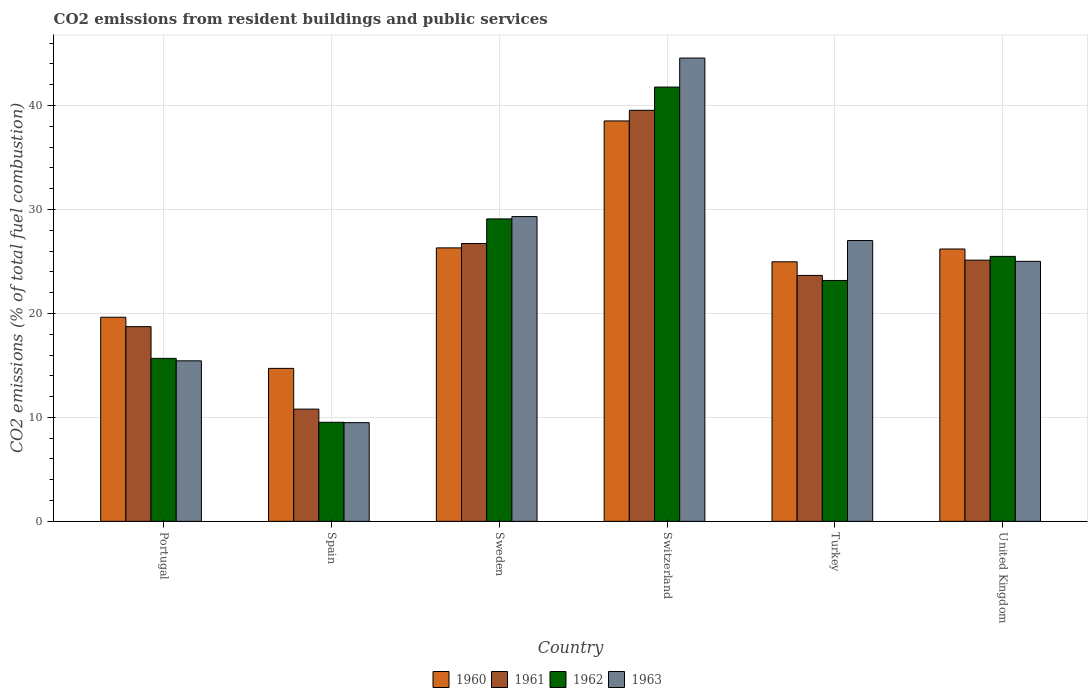How many different coloured bars are there?
Offer a very short reply. 4. Are the number of bars on each tick of the X-axis equal?
Your response must be concise. Yes. How many bars are there on the 3rd tick from the left?
Your answer should be very brief. 4. What is the label of the 5th group of bars from the left?
Keep it short and to the point. Turkey. What is the total CO2 emitted in 1961 in Switzerland?
Your answer should be compact. 39.54. Across all countries, what is the maximum total CO2 emitted in 1961?
Provide a succinct answer. 39.54. Across all countries, what is the minimum total CO2 emitted in 1962?
Your answer should be compact. 9.53. In which country was the total CO2 emitted in 1962 maximum?
Offer a terse response. Switzerland. What is the total total CO2 emitted in 1963 in the graph?
Give a very brief answer. 150.86. What is the difference between the total CO2 emitted in 1960 in Portugal and that in United Kingdom?
Your answer should be very brief. -6.57. What is the difference between the total CO2 emitted in 1960 in Sweden and the total CO2 emitted in 1961 in Portugal?
Keep it short and to the point. 7.58. What is the average total CO2 emitted in 1963 per country?
Provide a short and direct response. 25.14. What is the difference between the total CO2 emitted of/in 1961 and total CO2 emitted of/in 1962 in Spain?
Make the answer very short. 1.27. What is the ratio of the total CO2 emitted in 1962 in Switzerland to that in United Kingdom?
Provide a short and direct response. 1.64. Is the difference between the total CO2 emitted in 1961 in Portugal and Switzerland greater than the difference between the total CO2 emitted in 1962 in Portugal and Switzerland?
Offer a terse response. Yes. What is the difference between the highest and the second highest total CO2 emitted in 1963?
Your response must be concise. -17.56. What is the difference between the highest and the lowest total CO2 emitted in 1962?
Provide a succinct answer. 32.25. In how many countries, is the total CO2 emitted in 1961 greater than the average total CO2 emitted in 1961 taken over all countries?
Offer a very short reply. 3. Is the sum of the total CO2 emitted in 1960 in Spain and Turkey greater than the maximum total CO2 emitted in 1961 across all countries?
Provide a succinct answer. Yes. Is it the case that in every country, the sum of the total CO2 emitted in 1962 and total CO2 emitted in 1961 is greater than the total CO2 emitted in 1960?
Provide a short and direct response. Yes. How many bars are there?
Provide a short and direct response. 24. Are all the bars in the graph horizontal?
Offer a very short reply. No. Are the values on the major ticks of Y-axis written in scientific E-notation?
Offer a terse response. No. Where does the legend appear in the graph?
Your answer should be compact. Bottom center. How many legend labels are there?
Your answer should be very brief. 4. What is the title of the graph?
Offer a terse response. CO2 emissions from resident buildings and public services. Does "1995" appear as one of the legend labels in the graph?
Give a very brief answer. No. What is the label or title of the X-axis?
Keep it short and to the point. Country. What is the label or title of the Y-axis?
Your answer should be compact. CO2 emissions (% of total fuel combustion). What is the CO2 emissions (% of total fuel combustion) in 1960 in Portugal?
Ensure brevity in your answer.  19.64. What is the CO2 emissions (% of total fuel combustion) of 1961 in Portugal?
Your answer should be compact. 18.73. What is the CO2 emissions (% of total fuel combustion) of 1962 in Portugal?
Your response must be concise. 15.68. What is the CO2 emissions (% of total fuel combustion) in 1963 in Portugal?
Ensure brevity in your answer.  15.44. What is the CO2 emissions (% of total fuel combustion) in 1960 in Spain?
Offer a terse response. 14.72. What is the CO2 emissions (% of total fuel combustion) in 1961 in Spain?
Ensure brevity in your answer.  10.8. What is the CO2 emissions (% of total fuel combustion) of 1962 in Spain?
Provide a short and direct response. 9.53. What is the CO2 emissions (% of total fuel combustion) in 1963 in Spain?
Your response must be concise. 9.5. What is the CO2 emissions (% of total fuel combustion) of 1960 in Sweden?
Your answer should be very brief. 26.31. What is the CO2 emissions (% of total fuel combustion) of 1961 in Sweden?
Provide a short and direct response. 26.73. What is the CO2 emissions (% of total fuel combustion) in 1962 in Sweden?
Your answer should be compact. 29.1. What is the CO2 emissions (% of total fuel combustion) in 1963 in Sweden?
Provide a short and direct response. 29.32. What is the CO2 emissions (% of total fuel combustion) of 1960 in Switzerland?
Provide a short and direct response. 38.52. What is the CO2 emissions (% of total fuel combustion) of 1961 in Switzerland?
Make the answer very short. 39.54. What is the CO2 emissions (% of total fuel combustion) of 1962 in Switzerland?
Your response must be concise. 41.78. What is the CO2 emissions (% of total fuel combustion) in 1963 in Switzerland?
Your response must be concise. 44.57. What is the CO2 emissions (% of total fuel combustion) in 1960 in Turkey?
Make the answer very short. 24.97. What is the CO2 emissions (% of total fuel combustion) of 1961 in Turkey?
Give a very brief answer. 23.66. What is the CO2 emissions (% of total fuel combustion) in 1962 in Turkey?
Keep it short and to the point. 23.17. What is the CO2 emissions (% of total fuel combustion) in 1963 in Turkey?
Keep it short and to the point. 27.01. What is the CO2 emissions (% of total fuel combustion) of 1960 in United Kingdom?
Provide a succinct answer. 26.2. What is the CO2 emissions (% of total fuel combustion) in 1961 in United Kingdom?
Make the answer very short. 25.13. What is the CO2 emissions (% of total fuel combustion) in 1962 in United Kingdom?
Provide a short and direct response. 25.49. What is the CO2 emissions (% of total fuel combustion) in 1963 in United Kingdom?
Provide a short and direct response. 25.01. Across all countries, what is the maximum CO2 emissions (% of total fuel combustion) of 1960?
Your answer should be very brief. 38.52. Across all countries, what is the maximum CO2 emissions (% of total fuel combustion) of 1961?
Provide a short and direct response. 39.54. Across all countries, what is the maximum CO2 emissions (% of total fuel combustion) in 1962?
Your answer should be very brief. 41.78. Across all countries, what is the maximum CO2 emissions (% of total fuel combustion) of 1963?
Your answer should be compact. 44.57. Across all countries, what is the minimum CO2 emissions (% of total fuel combustion) of 1960?
Ensure brevity in your answer.  14.72. Across all countries, what is the minimum CO2 emissions (% of total fuel combustion) of 1961?
Your response must be concise. 10.8. Across all countries, what is the minimum CO2 emissions (% of total fuel combustion) of 1962?
Your response must be concise. 9.53. Across all countries, what is the minimum CO2 emissions (% of total fuel combustion) in 1963?
Make the answer very short. 9.5. What is the total CO2 emissions (% of total fuel combustion) of 1960 in the graph?
Your response must be concise. 150.36. What is the total CO2 emissions (% of total fuel combustion) of 1961 in the graph?
Provide a succinct answer. 144.59. What is the total CO2 emissions (% of total fuel combustion) in 1962 in the graph?
Provide a succinct answer. 144.75. What is the total CO2 emissions (% of total fuel combustion) in 1963 in the graph?
Provide a succinct answer. 150.86. What is the difference between the CO2 emissions (% of total fuel combustion) in 1960 in Portugal and that in Spain?
Keep it short and to the point. 4.92. What is the difference between the CO2 emissions (% of total fuel combustion) of 1961 in Portugal and that in Spain?
Give a very brief answer. 7.93. What is the difference between the CO2 emissions (% of total fuel combustion) in 1962 in Portugal and that in Spain?
Your response must be concise. 6.15. What is the difference between the CO2 emissions (% of total fuel combustion) of 1963 in Portugal and that in Spain?
Your response must be concise. 5.95. What is the difference between the CO2 emissions (% of total fuel combustion) of 1960 in Portugal and that in Sweden?
Offer a very short reply. -6.67. What is the difference between the CO2 emissions (% of total fuel combustion) in 1961 in Portugal and that in Sweden?
Your answer should be compact. -8. What is the difference between the CO2 emissions (% of total fuel combustion) of 1962 in Portugal and that in Sweden?
Ensure brevity in your answer.  -13.42. What is the difference between the CO2 emissions (% of total fuel combustion) in 1963 in Portugal and that in Sweden?
Give a very brief answer. -13.88. What is the difference between the CO2 emissions (% of total fuel combustion) of 1960 in Portugal and that in Switzerland?
Offer a very short reply. -18.88. What is the difference between the CO2 emissions (% of total fuel combustion) of 1961 in Portugal and that in Switzerland?
Ensure brevity in your answer.  -20.81. What is the difference between the CO2 emissions (% of total fuel combustion) in 1962 in Portugal and that in Switzerland?
Offer a very short reply. -26.1. What is the difference between the CO2 emissions (% of total fuel combustion) of 1963 in Portugal and that in Switzerland?
Keep it short and to the point. -29.13. What is the difference between the CO2 emissions (% of total fuel combustion) of 1960 in Portugal and that in Turkey?
Your response must be concise. -5.33. What is the difference between the CO2 emissions (% of total fuel combustion) in 1961 in Portugal and that in Turkey?
Ensure brevity in your answer.  -4.93. What is the difference between the CO2 emissions (% of total fuel combustion) in 1962 in Portugal and that in Turkey?
Provide a short and direct response. -7.5. What is the difference between the CO2 emissions (% of total fuel combustion) in 1963 in Portugal and that in Turkey?
Offer a terse response. -11.57. What is the difference between the CO2 emissions (% of total fuel combustion) of 1960 in Portugal and that in United Kingdom?
Ensure brevity in your answer.  -6.57. What is the difference between the CO2 emissions (% of total fuel combustion) of 1961 in Portugal and that in United Kingdom?
Make the answer very short. -6.4. What is the difference between the CO2 emissions (% of total fuel combustion) in 1962 in Portugal and that in United Kingdom?
Your answer should be compact. -9.81. What is the difference between the CO2 emissions (% of total fuel combustion) in 1963 in Portugal and that in United Kingdom?
Ensure brevity in your answer.  -9.57. What is the difference between the CO2 emissions (% of total fuel combustion) of 1960 in Spain and that in Sweden?
Keep it short and to the point. -11.59. What is the difference between the CO2 emissions (% of total fuel combustion) of 1961 in Spain and that in Sweden?
Provide a short and direct response. -15.93. What is the difference between the CO2 emissions (% of total fuel combustion) of 1962 in Spain and that in Sweden?
Make the answer very short. -19.57. What is the difference between the CO2 emissions (% of total fuel combustion) in 1963 in Spain and that in Sweden?
Offer a very short reply. -19.82. What is the difference between the CO2 emissions (% of total fuel combustion) of 1960 in Spain and that in Switzerland?
Offer a terse response. -23.8. What is the difference between the CO2 emissions (% of total fuel combustion) of 1961 in Spain and that in Switzerland?
Ensure brevity in your answer.  -28.75. What is the difference between the CO2 emissions (% of total fuel combustion) of 1962 in Spain and that in Switzerland?
Provide a short and direct response. -32.25. What is the difference between the CO2 emissions (% of total fuel combustion) of 1963 in Spain and that in Switzerland?
Provide a short and direct response. -35.07. What is the difference between the CO2 emissions (% of total fuel combustion) in 1960 in Spain and that in Turkey?
Give a very brief answer. -10.25. What is the difference between the CO2 emissions (% of total fuel combustion) in 1961 in Spain and that in Turkey?
Give a very brief answer. -12.86. What is the difference between the CO2 emissions (% of total fuel combustion) in 1962 in Spain and that in Turkey?
Make the answer very short. -13.64. What is the difference between the CO2 emissions (% of total fuel combustion) of 1963 in Spain and that in Turkey?
Your response must be concise. -17.52. What is the difference between the CO2 emissions (% of total fuel combustion) of 1960 in Spain and that in United Kingdom?
Your response must be concise. -11.49. What is the difference between the CO2 emissions (% of total fuel combustion) of 1961 in Spain and that in United Kingdom?
Offer a terse response. -14.33. What is the difference between the CO2 emissions (% of total fuel combustion) in 1962 in Spain and that in United Kingdom?
Ensure brevity in your answer.  -15.96. What is the difference between the CO2 emissions (% of total fuel combustion) of 1963 in Spain and that in United Kingdom?
Your answer should be very brief. -15.52. What is the difference between the CO2 emissions (% of total fuel combustion) in 1960 in Sweden and that in Switzerland?
Your response must be concise. -12.21. What is the difference between the CO2 emissions (% of total fuel combustion) of 1961 in Sweden and that in Switzerland?
Your answer should be very brief. -12.81. What is the difference between the CO2 emissions (% of total fuel combustion) of 1962 in Sweden and that in Switzerland?
Offer a terse response. -12.68. What is the difference between the CO2 emissions (% of total fuel combustion) of 1963 in Sweden and that in Switzerland?
Give a very brief answer. -15.25. What is the difference between the CO2 emissions (% of total fuel combustion) of 1960 in Sweden and that in Turkey?
Your response must be concise. 1.34. What is the difference between the CO2 emissions (% of total fuel combustion) in 1961 in Sweden and that in Turkey?
Your answer should be very brief. 3.07. What is the difference between the CO2 emissions (% of total fuel combustion) in 1962 in Sweden and that in Turkey?
Your answer should be very brief. 5.92. What is the difference between the CO2 emissions (% of total fuel combustion) of 1963 in Sweden and that in Turkey?
Your answer should be compact. 2.3. What is the difference between the CO2 emissions (% of total fuel combustion) of 1960 in Sweden and that in United Kingdom?
Your response must be concise. 0.11. What is the difference between the CO2 emissions (% of total fuel combustion) in 1961 in Sweden and that in United Kingdom?
Your response must be concise. 1.6. What is the difference between the CO2 emissions (% of total fuel combustion) in 1962 in Sweden and that in United Kingdom?
Give a very brief answer. 3.61. What is the difference between the CO2 emissions (% of total fuel combustion) in 1963 in Sweden and that in United Kingdom?
Offer a terse response. 4.3. What is the difference between the CO2 emissions (% of total fuel combustion) of 1960 in Switzerland and that in Turkey?
Provide a succinct answer. 13.55. What is the difference between the CO2 emissions (% of total fuel combustion) in 1961 in Switzerland and that in Turkey?
Make the answer very short. 15.88. What is the difference between the CO2 emissions (% of total fuel combustion) of 1962 in Switzerland and that in Turkey?
Make the answer very short. 18.6. What is the difference between the CO2 emissions (% of total fuel combustion) of 1963 in Switzerland and that in Turkey?
Provide a short and direct response. 17.56. What is the difference between the CO2 emissions (% of total fuel combustion) of 1960 in Switzerland and that in United Kingdom?
Ensure brevity in your answer.  12.32. What is the difference between the CO2 emissions (% of total fuel combustion) of 1961 in Switzerland and that in United Kingdom?
Offer a terse response. 14.42. What is the difference between the CO2 emissions (% of total fuel combustion) of 1962 in Switzerland and that in United Kingdom?
Provide a short and direct response. 16.29. What is the difference between the CO2 emissions (% of total fuel combustion) of 1963 in Switzerland and that in United Kingdom?
Make the answer very short. 19.56. What is the difference between the CO2 emissions (% of total fuel combustion) of 1960 in Turkey and that in United Kingdom?
Provide a succinct answer. -1.23. What is the difference between the CO2 emissions (% of total fuel combustion) of 1961 in Turkey and that in United Kingdom?
Keep it short and to the point. -1.47. What is the difference between the CO2 emissions (% of total fuel combustion) in 1962 in Turkey and that in United Kingdom?
Provide a succinct answer. -2.32. What is the difference between the CO2 emissions (% of total fuel combustion) of 1960 in Portugal and the CO2 emissions (% of total fuel combustion) of 1961 in Spain?
Your answer should be compact. 8.84. What is the difference between the CO2 emissions (% of total fuel combustion) in 1960 in Portugal and the CO2 emissions (% of total fuel combustion) in 1962 in Spain?
Your answer should be compact. 10.11. What is the difference between the CO2 emissions (% of total fuel combustion) in 1960 in Portugal and the CO2 emissions (% of total fuel combustion) in 1963 in Spain?
Offer a terse response. 10.14. What is the difference between the CO2 emissions (% of total fuel combustion) in 1961 in Portugal and the CO2 emissions (% of total fuel combustion) in 1962 in Spain?
Your response must be concise. 9.2. What is the difference between the CO2 emissions (% of total fuel combustion) in 1961 in Portugal and the CO2 emissions (% of total fuel combustion) in 1963 in Spain?
Ensure brevity in your answer.  9.23. What is the difference between the CO2 emissions (% of total fuel combustion) of 1962 in Portugal and the CO2 emissions (% of total fuel combustion) of 1963 in Spain?
Keep it short and to the point. 6.18. What is the difference between the CO2 emissions (% of total fuel combustion) in 1960 in Portugal and the CO2 emissions (% of total fuel combustion) in 1961 in Sweden?
Your response must be concise. -7.09. What is the difference between the CO2 emissions (% of total fuel combustion) in 1960 in Portugal and the CO2 emissions (% of total fuel combustion) in 1962 in Sweden?
Your answer should be compact. -9.46. What is the difference between the CO2 emissions (% of total fuel combustion) of 1960 in Portugal and the CO2 emissions (% of total fuel combustion) of 1963 in Sweden?
Your answer should be very brief. -9.68. What is the difference between the CO2 emissions (% of total fuel combustion) of 1961 in Portugal and the CO2 emissions (% of total fuel combustion) of 1962 in Sweden?
Provide a short and direct response. -10.36. What is the difference between the CO2 emissions (% of total fuel combustion) of 1961 in Portugal and the CO2 emissions (% of total fuel combustion) of 1963 in Sweden?
Your response must be concise. -10.59. What is the difference between the CO2 emissions (% of total fuel combustion) of 1962 in Portugal and the CO2 emissions (% of total fuel combustion) of 1963 in Sweden?
Ensure brevity in your answer.  -13.64. What is the difference between the CO2 emissions (% of total fuel combustion) in 1960 in Portugal and the CO2 emissions (% of total fuel combustion) in 1961 in Switzerland?
Give a very brief answer. -19.91. What is the difference between the CO2 emissions (% of total fuel combustion) of 1960 in Portugal and the CO2 emissions (% of total fuel combustion) of 1962 in Switzerland?
Make the answer very short. -22.14. What is the difference between the CO2 emissions (% of total fuel combustion) of 1960 in Portugal and the CO2 emissions (% of total fuel combustion) of 1963 in Switzerland?
Give a very brief answer. -24.93. What is the difference between the CO2 emissions (% of total fuel combustion) in 1961 in Portugal and the CO2 emissions (% of total fuel combustion) in 1962 in Switzerland?
Ensure brevity in your answer.  -23.05. What is the difference between the CO2 emissions (% of total fuel combustion) of 1961 in Portugal and the CO2 emissions (% of total fuel combustion) of 1963 in Switzerland?
Provide a succinct answer. -25.84. What is the difference between the CO2 emissions (% of total fuel combustion) of 1962 in Portugal and the CO2 emissions (% of total fuel combustion) of 1963 in Switzerland?
Your answer should be very brief. -28.89. What is the difference between the CO2 emissions (% of total fuel combustion) of 1960 in Portugal and the CO2 emissions (% of total fuel combustion) of 1961 in Turkey?
Your response must be concise. -4.02. What is the difference between the CO2 emissions (% of total fuel combustion) of 1960 in Portugal and the CO2 emissions (% of total fuel combustion) of 1962 in Turkey?
Your answer should be very brief. -3.54. What is the difference between the CO2 emissions (% of total fuel combustion) of 1960 in Portugal and the CO2 emissions (% of total fuel combustion) of 1963 in Turkey?
Give a very brief answer. -7.38. What is the difference between the CO2 emissions (% of total fuel combustion) of 1961 in Portugal and the CO2 emissions (% of total fuel combustion) of 1962 in Turkey?
Your answer should be very brief. -4.44. What is the difference between the CO2 emissions (% of total fuel combustion) of 1961 in Portugal and the CO2 emissions (% of total fuel combustion) of 1963 in Turkey?
Offer a terse response. -8.28. What is the difference between the CO2 emissions (% of total fuel combustion) in 1962 in Portugal and the CO2 emissions (% of total fuel combustion) in 1963 in Turkey?
Your answer should be very brief. -11.34. What is the difference between the CO2 emissions (% of total fuel combustion) in 1960 in Portugal and the CO2 emissions (% of total fuel combustion) in 1961 in United Kingdom?
Offer a terse response. -5.49. What is the difference between the CO2 emissions (% of total fuel combustion) of 1960 in Portugal and the CO2 emissions (% of total fuel combustion) of 1962 in United Kingdom?
Ensure brevity in your answer.  -5.85. What is the difference between the CO2 emissions (% of total fuel combustion) in 1960 in Portugal and the CO2 emissions (% of total fuel combustion) in 1963 in United Kingdom?
Keep it short and to the point. -5.38. What is the difference between the CO2 emissions (% of total fuel combustion) in 1961 in Portugal and the CO2 emissions (% of total fuel combustion) in 1962 in United Kingdom?
Provide a succinct answer. -6.76. What is the difference between the CO2 emissions (% of total fuel combustion) of 1961 in Portugal and the CO2 emissions (% of total fuel combustion) of 1963 in United Kingdom?
Keep it short and to the point. -6.28. What is the difference between the CO2 emissions (% of total fuel combustion) of 1962 in Portugal and the CO2 emissions (% of total fuel combustion) of 1963 in United Kingdom?
Ensure brevity in your answer.  -9.34. What is the difference between the CO2 emissions (% of total fuel combustion) of 1960 in Spain and the CO2 emissions (% of total fuel combustion) of 1961 in Sweden?
Make the answer very short. -12.01. What is the difference between the CO2 emissions (% of total fuel combustion) in 1960 in Spain and the CO2 emissions (% of total fuel combustion) in 1962 in Sweden?
Offer a very short reply. -14.38. What is the difference between the CO2 emissions (% of total fuel combustion) of 1960 in Spain and the CO2 emissions (% of total fuel combustion) of 1963 in Sweden?
Give a very brief answer. -14.6. What is the difference between the CO2 emissions (% of total fuel combustion) of 1961 in Spain and the CO2 emissions (% of total fuel combustion) of 1962 in Sweden?
Your answer should be compact. -18.3. What is the difference between the CO2 emissions (% of total fuel combustion) of 1961 in Spain and the CO2 emissions (% of total fuel combustion) of 1963 in Sweden?
Ensure brevity in your answer.  -18.52. What is the difference between the CO2 emissions (% of total fuel combustion) in 1962 in Spain and the CO2 emissions (% of total fuel combustion) in 1963 in Sweden?
Provide a short and direct response. -19.79. What is the difference between the CO2 emissions (% of total fuel combustion) in 1960 in Spain and the CO2 emissions (% of total fuel combustion) in 1961 in Switzerland?
Offer a terse response. -24.83. What is the difference between the CO2 emissions (% of total fuel combustion) of 1960 in Spain and the CO2 emissions (% of total fuel combustion) of 1962 in Switzerland?
Your answer should be compact. -27.06. What is the difference between the CO2 emissions (% of total fuel combustion) in 1960 in Spain and the CO2 emissions (% of total fuel combustion) in 1963 in Switzerland?
Your answer should be compact. -29.85. What is the difference between the CO2 emissions (% of total fuel combustion) of 1961 in Spain and the CO2 emissions (% of total fuel combustion) of 1962 in Switzerland?
Keep it short and to the point. -30.98. What is the difference between the CO2 emissions (% of total fuel combustion) of 1961 in Spain and the CO2 emissions (% of total fuel combustion) of 1963 in Switzerland?
Provide a short and direct response. -33.77. What is the difference between the CO2 emissions (% of total fuel combustion) of 1962 in Spain and the CO2 emissions (% of total fuel combustion) of 1963 in Switzerland?
Your answer should be very brief. -35.04. What is the difference between the CO2 emissions (% of total fuel combustion) of 1960 in Spain and the CO2 emissions (% of total fuel combustion) of 1961 in Turkey?
Your answer should be very brief. -8.94. What is the difference between the CO2 emissions (% of total fuel combustion) of 1960 in Spain and the CO2 emissions (% of total fuel combustion) of 1962 in Turkey?
Ensure brevity in your answer.  -8.46. What is the difference between the CO2 emissions (% of total fuel combustion) of 1960 in Spain and the CO2 emissions (% of total fuel combustion) of 1963 in Turkey?
Your answer should be compact. -12.3. What is the difference between the CO2 emissions (% of total fuel combustion) in 1961 in Spain and the CO2 emissions (% of total fuel combustion) in 1962 in Turkey?
Provide a succinct answer. -12.38. What is the difference between the CO2 emissions (% of total fuel combustion) in 1961 in Spain and the CO2 emissions (% of total fuel combustion) in 1963 in Turkey?
Offer a very short reply. -16.22. What is the difference between the CO2 emissions (% of total fuel combustion) in 1962 in Spain and the CO2 emissions (% of total fuel combustion) in 1963 in Turkey?
Make the answer very short. -17.48. What is the difference between the CO2 emissions (% of total fuel combustion) in 1960 in Spain and the CO2 emissions (% of total fuel combustion) in 1961 in United Kingdom?
Your answer should be very brief. -10.41. What is the difference between the CO2 emissions (% of total fuel combustion) in 1960 in Spain and the CO2 emissions (% of total fuel combustion) in 1962 in United Kingdom?
Offer a very short reply. -10.77. What is the difference between the CO2 emissions (% of total fuel combustion) of 1960 in Spain and the CO2 emissions (% of total fuel combustion) of 1963 in United Kingdom?
Your answer should be compact. -10.3. What is the difference between the CO2 emissions (% of total fuel combustion) in 1961 in Spain and the CO2 emissions (% of total fuel combustion) in 1962 in United Kingdom?
Your answer should be compact. -14.69. What is the difference between the CO2 emissions (% of total fuel combustion) in 1961 in Spain and the CO2 emissions (% of total fuel combustion) in 1963 in United Kingdom?
Provide a succinct answer. -14.22. What is the difference between the CO2 emissions (% of total fuel combustion) in 1962 in Spain and the CO2 emissions (% of total fuel combustion) in 1963 in United Kingdom?
Offer a very short reply. -15.48. What is the difference between the CO2 emissions (% of total fuel combustion) in 1960 in Sweden and the CO2 emissions (% of total fuel combustion) in 1961 in Switzerland?
Your answer should be compact. -13.23. What is the difference between the CO2 emissions (% of total fuel combustion) in 1960 in Sweden and the CO2 emissions (% of total fuel combustion) in 1962 in Switzerland?
Provide a succinct answer. -15.47. What is the difference between the CO2 emissions (% of total fuel combustion) of 1960 in Sweden and the CO2 emissions (% of total fuel combustion) of 1963 in Switzerland?
Keep it short and to the point. -18.26. What is the difference between the CO2 emissions (% of total fuel combustion) of 1961 in Sweden and the CO2 emissions (% of total fuel combustion) of 1962 in Switzerland?
Provide a succinct answer. -15.05. What is the difference between the CO2 emissions (% of total fuel combustion) of 1961 in Sweden and the CO2 emissions (% of total fuel combustion) of 1963 in Switzerland?
Your response must be concise. -17.84. What is the difference between the CO2 emissions (% of total fuel combustion) of 1962 in Sweden and the CO2 emissions (% of total fuel combustion) of 1963 in Switzerland?
Your response must be concise. -15.47. What is the difference between the CO2 emissions (% of total fuel combustion) of 1960 in Sweden and the CO2 emissions (% of total fuel combustion) of 1961 in Turkey?
Keep it short and to the point. 2.65. What is the difference between the CO2 emissions (% of total fuel combustion) of 1960 in Sweden and the CO2 emissions (% of total fuel combustion) of 1962 in Turkey?
Make the answer very short. 3.14. What is the difference between the CO2 emissions (% of total fuel combustion) in 1960 in Sweden and the CO2 emissions (% of total fuel combustion) in 1963 in Turkey?
Your response must be concise. -0.71. What is the difference between the CO2 emissions (% of total fuel combustion) in 1961 in Sweden and the CO2 emissions (% of total fuel combustion) in 1962 in Turkey?
Keep it short and to the point. 3.56. What is the difference between the CO2 emissions (% of total fuel combustion) in 1961 in Sweden and the CO2 emissions (% of total fuel combustion) in 1963 in Turkey?
Offer a terse response. -0.29. What is the difference between the CO2 emissions (% of total fuel combustion) in 1962 in Sweden and the CO2 emissions (% of total fuel combustion) in 1963 in Turkey?
Offer a very short reply. 2.08. What is the difference between the CO2 emissions (% of total fuel combustion) of 1960 in Sweden and the CO2 emissions (% of total fuel combustion) of 1961 in United Kingdom?
Ensure brevity in your answer.  1.18. What is the difference between the CO2 emissions (% of total fuel combustion) of 1960 in Sweden and the CO2 emissions (% of total fuel combustion) of 1962 in United Kingdom?
Make the answer very short. 0.82. What is the difference between the CO2 emissions (% of total fuel combustion) of 1960 in Sweden and the CO2 emissions (% of total fuel combustion) of 1963 in United Kingdom?
Your response must be concise. 1.29. What is the difference between the CO2 emissions (% of total fuel combustion) in 1961 in Sweden and the CO2 emissions (% of total fuel combustion) in 1962 in United Kingdom?
Provide a short and direct response. 1.24. What is the difference between the CO2 emissions (% of total fuel combustion) in 1961 in Sweden and the CO2 emissions (% of total fuel combustion) in 1963 in United Kingdom?
Your answer should be very brief. 1.71. What is the difference between the CO2 emissions (% of total fuel combustion) of 1962 in Sweden and the CO2 emissions (% of total fuel combustion) of 1963 in United Kingdom?
Provide a short and direct response. 4.08. What is the difference between the CO2 emissions (% of total fuel combustion) in 1960 in Switzerland and the CO2 emissions (% of total fuel combustion) in 1961 in Turkey?
Give a very brief answer. 14.86. What is the difference between the CO2 emissions (% of total fuel combustion) of 1960 in Switzerland and the CO2 emissions (% of total fuel combustion) of 1962 in Turkey?
Give a very brief answer. 15.35. What is the difference between the CO2 emissions (% of total fuel combustion) of 1960 in Switzerland and the CO2 emissions (% of total fuel combustion) of 1963 in Turkey?
Ensure brevity in your answer.  11.51. What is the difference between the CO2 emissions (% of total fuel combustion) in 1961 in Switzerland and the CO2 emissions (% of total fuel combustion) in 1962 in Turkey?
Make the answer very short. 16.37. What is the difference between the CO2 emissions (% of total fuel combustion) of 1961 in Switzerland and the CO2 emissions (% of total fuel combustion) of 1963 in Turkey?
Provide a short and direct response. 12.53. What is the difference between the CO2 emissions (% of total fuel combustion) of 1962 in Switzerland and the CO2 emissions (% of total fuel combustion) of 1963 in Turkey?
Your response must be concise. 14.76. What is the difference between the CO2 emissions (% of total fuel combustion) in 1960 in Switzerland and the CO2 emissions (% of total fuel combustion) in 1961 in United Kingdom?
Keep it short and to the point. 13.39. What is the difference between the CO2 emissions (% of total fuel combustion) in 1960 in Switzerland and the CO2 emissions (% of total fuel combustion) in 1962 in United Kingdom?
Offer a very short reply. 13.03. What is the difference between the CO2 emissions (% of total fuel combustion) in 1960 in Switzerland and the CO2 emissions (% of total fuel combustion) in 1963 in United Kingdom?
Keep it short and to the point. 13.51. What is the difference between the CO2 emissions (% of total fuel combustion) in 1961 in Switzerland and the CO2 emissions (% of total fuel combustion) in 1962 in United Kingdom?
Offer a terse response. 14.05. What is the difference between the CO2 emissions (% of total fuel combustion) of 1961 in Switzerland and the CO2 emissions (% of total fuel combustion) of 1963 in United Kingdom?
Provide a short and direct response. 14.53. What is the difference between the CO2 emissions (% of total fuel combustion) of 1962 in Switzerland and the CO2 emissions (% of total fuel combustion) of 1963 in United Kingdom?
Keep it short and to the point. 16.76. What is the difference between the CO2 emissions (% of total fuel combustion) in 1960 in Turkey and the CO2 emissions (% of total fuel combustion) in 1961 in United Kingdom?
Offer a very short reply. -0.16. What is the difference between the CO2 emissions (% of total fuel combustion) in 1960 in Turkey and the CO2 emissions (% of total fuel combustion) in 1962 in United Kingdom?
Your response must be concise. -0.52. What is the difference between the CO2 emissions (% of total fuel combustion) in 1960 in Turkey and the CO2 emissions (% of total fuel combustion) in 1963 in United Kingdom?
Make the answer very short. -0.05. What is the difference between the CO2 emissions (% of total fuel combustion) of 1961 in Turkey and the CO2 emissions (% of total fuel combustion) of 1962 in United Kingdom?
Ensure brevity in your answer.  -1.83. What is the difference between the CO2 emissions (% of total fuel combustion) of 1961 in Turkey and the CO2 emissions (% of total fuel combustion) of 1963 in United Kingdom?
Offer a very short reply. -1.35. What is the difference between the CO2 emissions (% of total fuel combustion) of 1962 in Turkey and the CO2 emissions (% of total fuel combustion) of 1963 in United Kingdom?
Make the answer very short. -1.84. What is the average CO2 emissions (% of total fuel combustion) of 1960 per country?
Your response must be concise. 25.06. What is the average CO2 emissions (% of total fuel combustion) in 1961 per country?
Your response must be concise. 24.1. What is the average CO2 emissions (% of total fuel combustion) in 1962 per country?
Keep it short and to the point. 24.12. What is the average CO2 emissions (% of total fuel combustion) of 1963 per country?
Your answer should be very brief. 25.14. What is the difference between the CO2 emissions (% of total fuel combustion) of 1960 and CO2 emissions (% of total fuel combustion) of 1961 in Portugal?
Offer a terse response. 0.91. What is the difference between the CO2 emissions (% of total fuel combustion) of 1960 and CO2 emissions (% of total fuel combustion) of 1962 in Portugal?
Give a very brief answer. 3.96. What is the difference between the CO2 emissions (% of total fuel combustion) in 1960 and CO2 emissions (% of total fuel combustion) in 1963 in Portugal?
Your answer should be compact. 4.19. What is the difference between the CO2 emissions (% of total fuel combustion) of 1961 and CO2 emissions (% of total fuel combustion) of 1962 in Portugal?
Your answer should be very brief. 3.05. What is the difference between the CO2 emissions (% of total fuel combustion) in 1961 and CO2 emissions (% of total fuel combustion) in 1963 in Portugal?
Make the answer very short. 3.29. What is the difference between the CO2 emissions (% of total fuel combustion) of 1962 and CO2 emissions (% of total fuel combustion) of 1963 in Portugal?
Provide a short and direct response. 0.23. What is the difference between the CO2 emissions (% of total fuel combustion) of 1960 and CO2 emissions (% of total fuel combustion) of 1961 in Spain?
Provide a short and direct response. 3.92. What is the difference between the CO2 emissions (% of total fuel combustion) of 1960 and CO2 emissions (% of total fuel combustion) of 1962 in Spain?
Your answer should be compact. 5.19. What is the difference between the CO2 emissions (% of total fuel combustion) in 1960 and CO2 emissions (% of total fuel combustion) in 1963 in Spain?
Ensure brevity in your answer.  5.22. What is the difference between the CO2 emissions (% of total fuel combustion) of 1961 and CO2 emissions (% of total fuel combustion) of 1962 in Spain?
Your response must be concise. 1.27. What is the difference between the CO2 emissions (% of total fuel combustion) of 1961 and CO2 emissions (% of total fuel combustion) of 1963 in Spain?
Offer a very short reply. 1.3. What is the difference between the CO2 emissions (% of total fuel combustion) in 1962 and CO2 emissions (% of total fuel combustion) in 1963 in Spain?
Keep it short and to the point. 0.03. What is the difference between the CO2 emissions (% of total fuel combustion) of 1960 and CO2 emissions (% of total fuel combustion) of 1961 in Sweden?
Your answer should be compact. -0.42. What is the difference between the CO2 emissions (% of total fuel combustion) of 1960 and CO2 emissions (% of total fuel combustion) of 1962 in Sweden?
Your response must be concise. -2.79. What is the difference between the CO2 emissions (% of total fuel combustion) in 1960 and CO2 emissions (% of total fuel combustion) in 1963 in Sweden?
Ensure brevity in your answer.  -3.01. What is the difference between the CO2 emissions (% of total fuel combustion) in 1961 and CO2 emissions (% of total fuel combustion) in 1962 in Sweden?
Offer a terse response. -2.37. What is the difference between the CO2 emissions (% of total fuel combustion) of 1961 and CO2 emissions (% of total fuel combustion) of 1963 in Sweden?
Your answer should be very brief. -2.59. What is the difference between the CO2 emissions (% of total fuel combustion) of 1962 and CO2 emissions (% of total fuel combustion) of 1963 in Sweden?
Your answer should be very brief. -0.22. What is the difference between the CO2 emissions (% of total fuel combustion) in 1960 and CO2 emissions (% of total fuel combustion) in 1961 in Switzerland?
Provide a succinct answer. -1.02. What is the difference between the CO2 emissions (% of total fuel combustion) of 1960 and CO2 emissions (% of total fuel combustion) of 1962 in Switzerland?
Offer a terse response. -3.26. What is the difference between the CO2 emissions (% of total fuel combustion) of 1960 and CO2 emissions (% of total fuel combustion) of 1963 in Switzerland?
Provide a succinct answer. -6.05. What is the difference between the CO2 emissions (% of total fuel combustion) in 1961 and CO2 emissions (% of total fuel combustion) in 1962 in Switzerland?
Your answer should be very brief. -2.23. What is the difference between the CO2 emissions (% of total fuel combustion) in 1961 and CO2 emissions (% of total fuel combustion) in 1963 in Switzerland?
Make the answer very short. -5.03. What is the difference between the CO2 emissions (% of total fuel combustion) of 1962 and CO2 emissions (% of total fuel combustion) of 1963 in Switzerland?
Provide a short and direct response. -2.79. What is the difference between the CO2 emissions (% of total fuel combustion) in 1960 and CO2 emissions (% of total fuel combustion) in 1961 in Turkey?
Your answer should be very brief. 1.31. What is the difference between the CO2 emissions (% of total fuel combustion) of 1960 and CO2 emissions (% of total fuel combustion) of 1962 in Turkey?
Ensure brevity in your answer.  1.8. What is the difference between the CO2 emissions (% of total fuel combustion) of 1960 and CO2 emissions (% of total fuel combustion) of 1963 in Turkey?
Your response must be concise. -2.05. What is the difference between the CO2 emissions (% of total fuel combustion) of 1961 and CO2 emissions (% of total fuel combustion) of 1962 in Turkey?
Your answer should be compact. 0.49. What is the difference between the CO2 emissions (% of total fuel combustion) of 1961 and CO2 emissions (% of total fuel combustion) of 1963 in Turkey?
Your answer should be compact. -3.35. What is the difference between the CO2 emissions (% of total fuel combustion) of 1962 and CO2 emissions (% of total fuel combustion) of 1963 in Turkey?
Your answer should be very brief. -3.84. What is the difference between the CO2 emissions (% of total fuel combustion) in 1960 and CO2 emissions (% of total fuel combustion) in 1961 in United Kingdom?
Your answer should be very brief. 1.07. What is the difference between the CO2 emissions (% of total fuel combustion) in 1960 and CO2 emissions (% of total fuel combustion) in 1962 in United Kingdom?
Give a very brief answer. 0.71. What is the difference between the CO2 emissions (% of total fuel combustion) of 1960 and CO2 emissions (% of total fuel combustion) of 1963 in United Kingdom?
Ensure brevity in your answer.  1.19. What is the difference between the CO2 emissions (% of total fuel combustion) of 1961 and CO2 emissions (% of total fuel combustion) of 1962 in United Kingdom?
Your response must be concise. -0.36. What is the difference between the CO2 emissions (% of total fuel combustion) in 1961 and CO2 emissions (% of total fuel combustion) in 1963 in United Kingdom?
Offer a terse response. 0.11. What is the difference between the CO2 emissions (% of total fuel combustion) of 1962 and CO2 emissions (% of total fuel combustion) of 1963 in United Kingdom?
Provide a succinct answer. 0.48. What is the ratio of the CO2 emissions (% of total fuel combustion) of 1960 in Portugal to that in Spain?
Offer a very short reply. 1.33. What is the ratio of the CO2 emissions (% of total fuel combustion) in 1961 in Portugal to that in Spain?
Give a very brief answer. 1.73. What is the ratio of the CO2 emissions (% of total fuel combustion) in 1962 in Portugal to that in Spain?
Your answer should be compact. 1.64. What is the ratio of the CO2 emissions (% of total fuel combustion) in 1963 in Portugal to that in Spain?
Make the answer very short. 1.63. What is the ratio of the CO2 emissions (% of total fuel combustion) of 1960 in Portugal to that in Sweden?
Keep it short and to the point. 0.75. What is the ratio of the CO2 emissions (% of total fuel combustion) of 1961 in Portugal to that in Sweden?
Your response must be concise. 0.7. What is the ratio of the CO2 emissions (% of total fuel combustion) in 1962 in Portugal to that in Sweden?
Keep it short and to the point. 0.54. What is the ratio of the CO2 emissions (% of total fuel combustion) in 1963 in Portugal to that in Sweden?
Your answer should be very brief. 0.53. What is the ratio of the CO2 emissions (% of total fuel combustion) in 1960 in Portugal to that in Switzerland?
Provide a succinct answer. 0.51. What is the ratio of the CO2 emissions (% of total fuel combustion) in 1961 in Portugal to that in Switzerland?
Provide a succinct answer. 0.47. What is the ratio of the CO2 emissions (% of total fuel combustion) of 1962 in Portugal to that in Switzerland?
Offer a terse response. 0.38. What is the ratio of the CO2 emissions (% of total fuel combustion) in 1963 in Portugal to that in Switzerland?
Make the answer very short. 0.35. What is the ratio of the CO2 emissions (% of total fuel combustion) in 1960 in Portugal to that in Turkey?
Your answer should be compact. 0.79. What is the ratio of the CO2 emissions (% of total fuel combustion) of 1961 in Portugal to that in Turkey?
Provide a succinct answer. 0.79. What is the ratio of the CO2 emissions (% of total fuel combustion) of 1962 in Portugal to that in Turkey?
Offer a terse response. 0.68. What is the ratio of the CO2 emissions (% of total fuel combustion) of 1963 in Portugal to that in Turkey?
Your answer should be very brief. 0.57. What is the ratio of the CO2 emissions (% of total fuel combustion) in 1960 in Portugal to that in United Kingdom?
Your answer should be compact. 0.75. What is the ratio of the CO2 emissions (% of total fuel combustion) in 1961 in Portugal to that in United Kingdom?
Your answer should be compact. 0.75. What is the ratio of the CO2 emissions (% of total fuel combustion) in 1962 in Portugal to that in United Kingdom?
Provide a short and direct response. 0.61. What is the ratio of the CO2 emissions (% of total fuel combustion) of 1963 in Portugal to that in United Kingdom?
Your answer should be compact. 0.62. What is the ratio of the CO2 emissions (% of total fuel combustion) of 1960 in Spain to that in Sweden?
Keep it short and to the point. 0.56. What is the ratio of the CO2 emissions (% of total fuel combustion) in 1961 in Spain to that in Sweden?
Provide a short and direct response. 0.4. What is the ratio of the CO2 emissions (% of total fuel combustion) of 1962 in Spain to that in Sweden?
Offer a very short reply. 0.33. What is the ratio of the CO2 emissions (% of total fuel combustion) of 1963 in Spain to that in Sweden?
Keep it short and to the point. 0.32. What is the ratio of the CO2 emissions (% of total fuel combustion) in 1960 in Spain to that in Switzerland?
Offer a terse response. 0.38. What is the ratio of the CO2 emissions (% of total fuel combustion) of 1961 in Spain to that in Switzerland?
Keep it short and to the point. 0.27. What is the ratio of the CO2 emissions (% of total fuel combustion) of 1962 in Spain to that in Switzerland?
Your answer should be compact. 0.23. What is the ratio of the CO2 emissions (% of total fuel combustion) of 1963 in Spain to that in Switzerland?
Your answer should be compact. 0.21. What is the ratio of the CO2 emissions (% of total fuel combustion) in 1960 in Spain to that in Turkey?
Your answer should be very brief. 0.59. What is the ratio of the CO2 emissions (% of total fuel combustion) of 1961 in Spain to that in Turkey?
Provide a short and direct response. 0.46. What is the ratio of the CO2 emissions (% of total fuel combustion) of 1962 in Spain to that in Turkey?
Your answer should be compact. 0.41. What is the ratio of the CO2 emissions (% of total fuel combustion) in 1963 in Spain to that in Turkey?
Your answer should be very brief. 0.35. What is the ratio of the CO2 emissions (% of total fuel combustion) in 1960 in Spain to that in United Kingdom?
Your answer should be compact. 0.56. What is the ratio of the CO2 emissions (% of total fuel combustion) in 1961 in Spain to that in United Kingdom?
Your answer should be compact. 0.43. What is the ratio of the CO2 emissions (% of total fuel combustion) of 1962 in Spain to that in United Kingdom?
Ensure brevity in your answer.  0.37. What is the ratio of the CO2 emissions (% of total fuel combustion) of 1963 in Spain to that in United Kingdom?
Offer a terse response. 0.38. What is the ratio of the CO2 emissions (% of total fuel combustion) of 1960 in Sweden to that in Switzerland?
Ensure brevity in your answer.  0.68. What is the ratio of the CO2 emissions (% of total fuel combustion) in 1961 in Sweden to that in Switzerland?
Ensure brevity in your answer.  0.68. What is the ratio of the CO2 emissions (% of total fuel combustion) in 1962 in Sweden to that in Switzerland?
Offer a very short reply. 0.7. What is the ratio of the CO2 emissions (% of total fuel combustion) in 1963 in Sweden to that in Switzerland?
Your answer should be compact. 0.66. What is the ratio of the CO2 emissions (% of total fuel combustion) in 1960 in Sweden to that in Turkey?
Your answer should be compact. 1.05. What is the ratio of the CO2 emissions (% of total fuel combustion) of 1961 in Sweden to that in Turkey?
Your response must be concise. 1.13. What is the ratio of the CO2 emissions (% of total fuel combustion) of 1962 in Sweden to that in Turkey?
Keep it short and to the point. 1.26. What is the ratio of the CO2 emissions (% of total fuel combustion) of 1963 in Sweden to that in Turkey?
Your answer should be very brief. 1.09. What is the ratio of the CO2 emissions (% of total fuel combustion) of 1960 in Sweden to that in United Kingdom?
Provide a short and direct response. 1. What is the ratio of the CO2 emissions (% of total fuel combustion) in 1961 in Sweden to that in United Kingdom?
Provide a succinct answer. 1.06. What is the ratio of the CO2 emissions (% of total fuel combustion) in 1962 in Sweden to that in United Kingdom?
Your response must be concise. 1.14. What is the ratio of the CO2 emissions (% of total fuel combustion) in 1963 in Sweden to that in United Kingdom?
Your answer should be compact. 1.17. What is the ratio of the CO2 emissions (% of total fuel combustion) of 1960 in Switzerland to that in Turkey?
Your answer should be very brief. 1.54. What is the ratio of the CO2 emissions (% of total fuel combustion) in 1961 in Switzerland to that in Turkey?
Provide a succinct answer. 1.67. What is the ratio of the CO2 emissions (% of total fuel combustion) of 1962 in Switzerland to that in Turkey?
Offer a terse response. 1.8. What is the ratio of the CO2 emissions (% of total fuel combustion) in 1963 in Switzerland to that in Turkey?
Keep it short and to the point. 1.65. What is the ratio of the CO2 emissions (% of total fuel combustion) in 1960 in Switzerland to that in United Kingdom?
Make the answer very short. 1.47. What is the ratio of the CO2 emissions (% of total fuel combustion) of 1961 in Switzerland to that in United Kingdom?
Your answer should be compact. 1.57. What is the ratio of the CO2 emissions (% of total fuel combustion) in 1962 in Switzerland to that in United Kingdom?
Provide a short and direct response. 1.64. What is the ratio of the CO2 emissions (% of total fuel combustion) in 1963 in Switzerland to that in United Kingdom?
Your answer should be very brief. 1.78. What is the ratio of the CO2 emissions (% of total fuel combustion) in 1960 in Turkey to that in United Kingdom?
Keep it short and to the point. 0.95. What is the ratio of the CO2 emissions (% of total fuel combustion) in 1961 in Turkey to that in United Kingdom?
Provide a short and direct response. 0.94. What is the difference between the highest and the second highest CO2 emissions (% of total fuel combustion) in 1960?
Your answer should be very brief. 12.21. What is the difference between the highest and the second highest CO2 emissions (% of total fuel combustion) of 1961?
Provide a succinct answer. 12.81. What is the difference between the highest and the second highest CO2 emissions (% of total fuel combustion) in 1962?
Provide a succinct answer. 12.68. What is the difference between the highest and the second highest CO2 emissions (% of total fuel combustion) in 1963?
Make the answer very short. 15.25. What is the difference between the highest and the lowest CO2 emissions (% of total fuel combustion) of 1960?
Your response must be concise. 23.8. What is the difference between the highest and the lowest CO2 emissions (% of total fuel combustion) of 1961?
Your answer should be compact. 28.75. What is the difference between the highest and the lowest CO2 emissions (% of total fuel combustion) of 1962?
Your answer should be compact. 32.25. What is the difference between the highest and the lowest CO2 emissions (% of total fuel combustion) of 1963?
Your response must be concise. 35.07. 